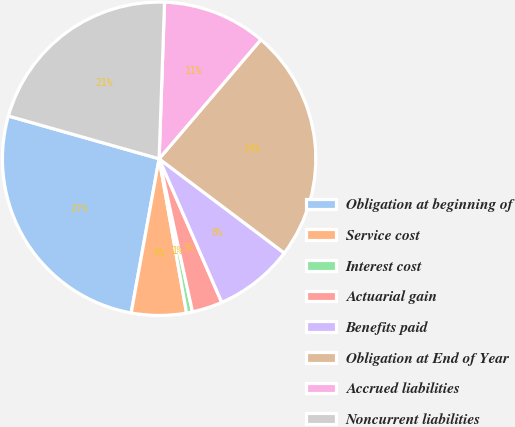Convert chart. <chart><loc_0><loc_0><loc_500><loc_500><pie_chart><fcel>Obligation at beginning of<fcel>Service cost<fcel>Interest cost<fcel>Actuarial gain<fcel>Benefits paid<fcel>Obligation at End of Year<fcel>Accrued liabilities<fcel>Noncurrent liabilities<nl><fcel>26.55%<fcel>5.66%<fcel>0.61%<fcel>3.13%<fcel>8.18%<fcel>24.02%<fcel>10.7%<fcel>21.15%<nl></chart> 